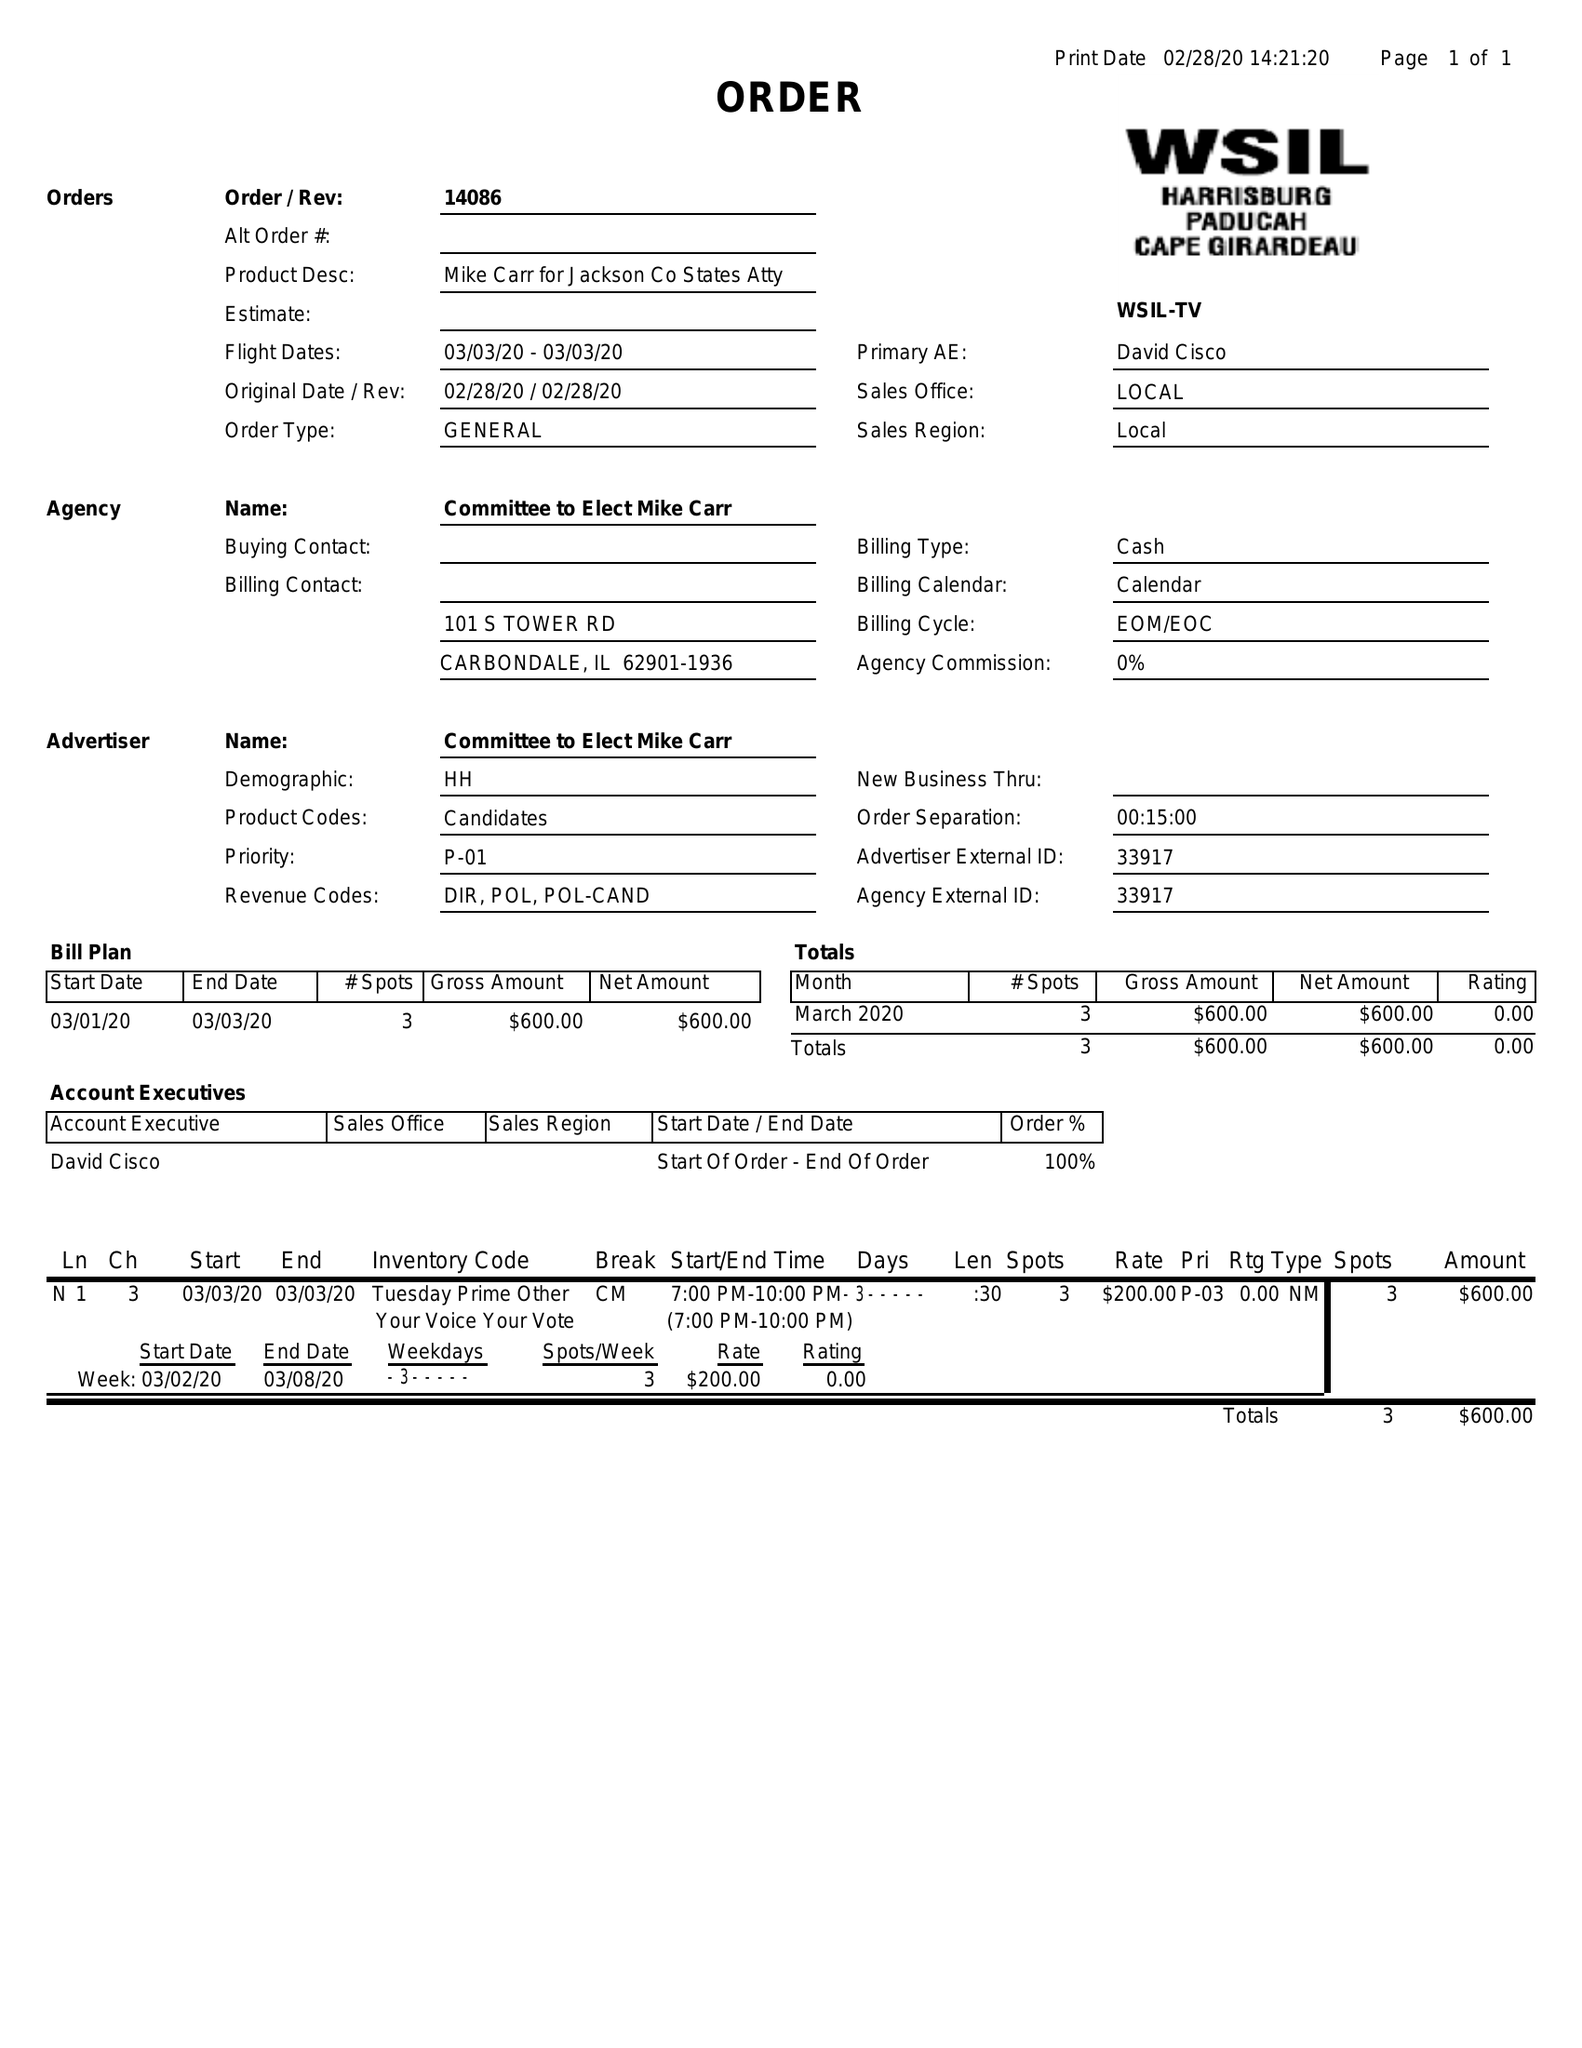What is the value for the flight_from?
Answer the question using a single word or phrase. 03/03/20 